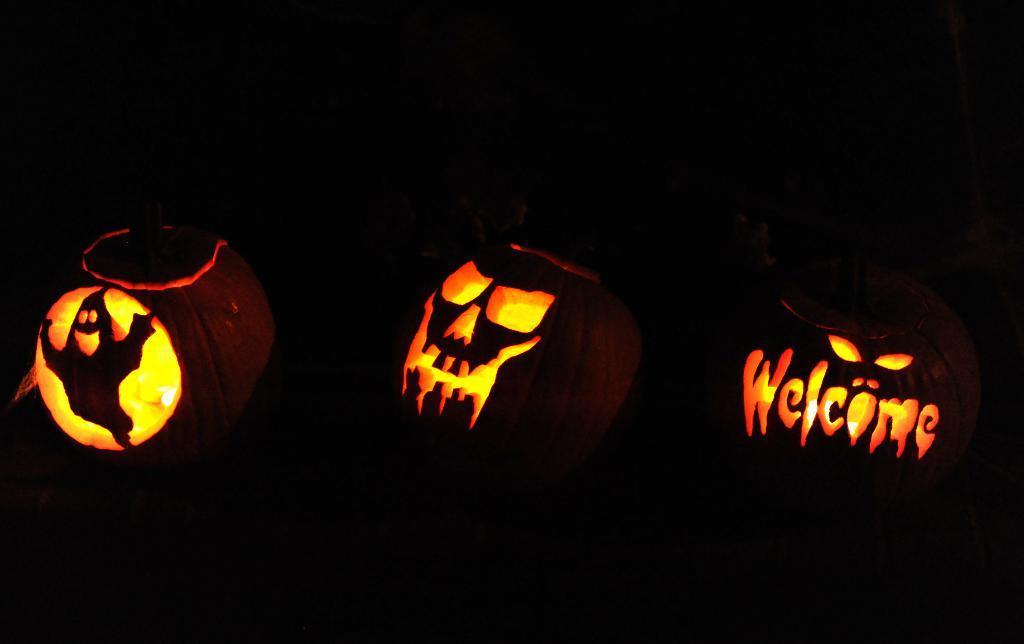Please provide a concise description of this image. In this image there are carvings on the pumpkin. It seems like a halloween. This image is taken in the dark. 